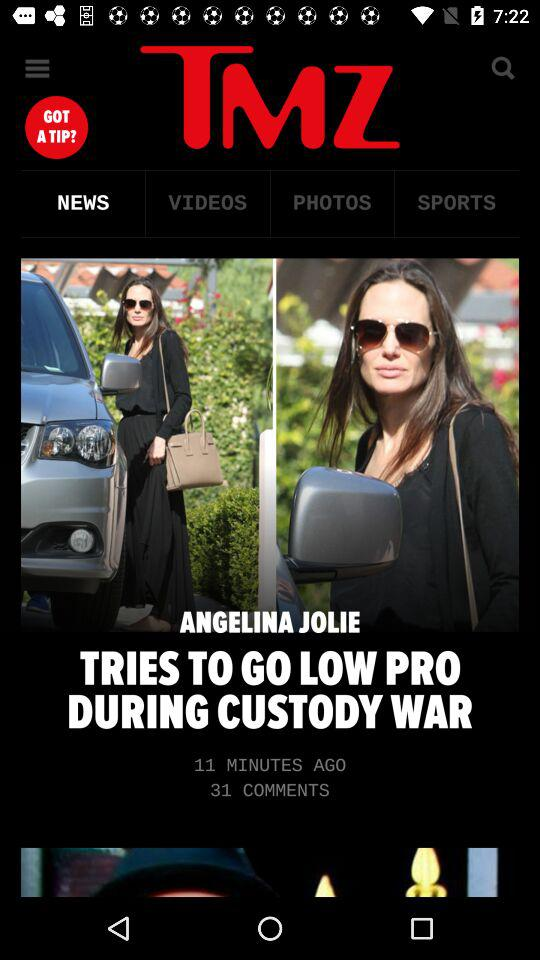What is the headline of the news? The headline of the news is "ANGELINA JOLIE TRIES TO GO LOW PRO DURING CUSTODY WAR". 